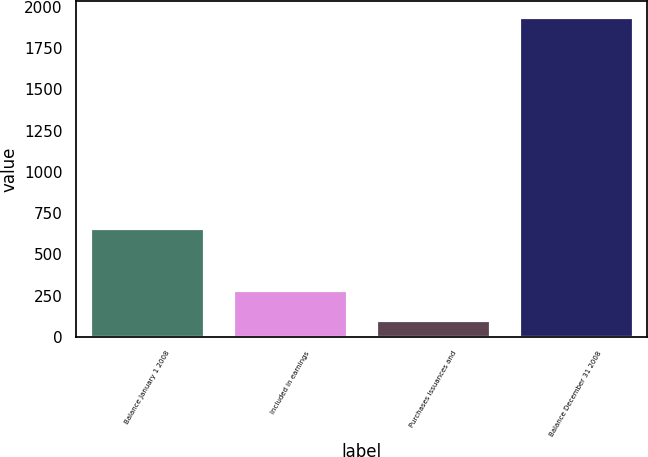Convert chart. <chart><loc_0><loc_0><loc_500><loc_500><bar_chart><fcel>Balance January 1 2008<fcel>Included in earnings<fcel>Purchases issuances and<fcel>Balance December 31 2008<nl><fcel>660<fcel>284.9<fcel>101<fcel>1940<nl></chart> 